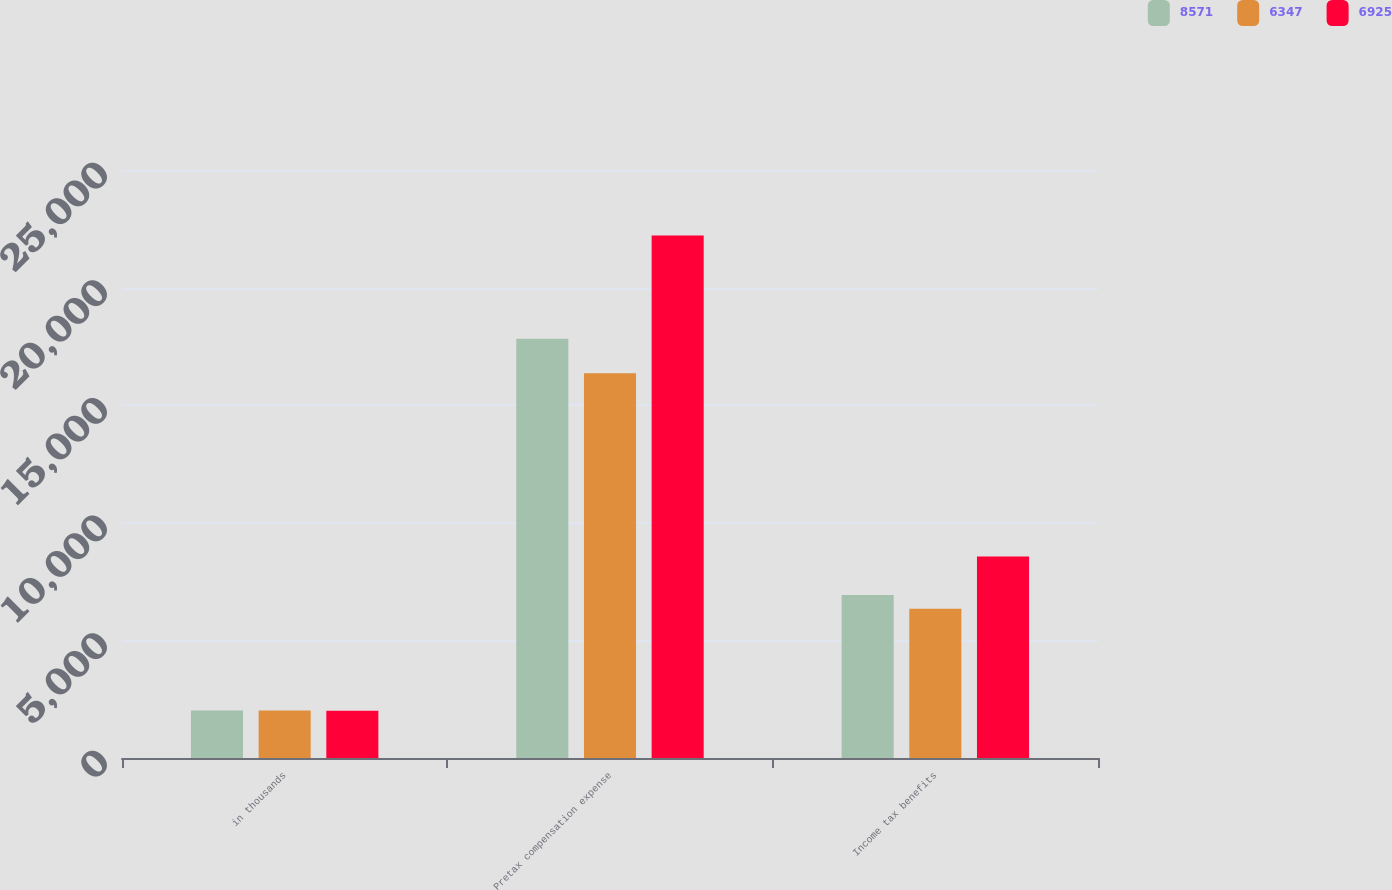Convert chart. <chart><loc_0><loc_0><loc_500><loc_500><stacked_bar_chart><ecel><fcel>in thousands<fcel>Pretax compensation expense<fcel>Income tax benefits<nl><fcel>8571<fcel>2016<fcel>17823<fcel>6925<nl><fcel>6347<fcel>2015<fcel>16362<fcel>6347<nl><fcel>6925<fcel>2014<fcel>22217<fcel>8571<nl></chart> 